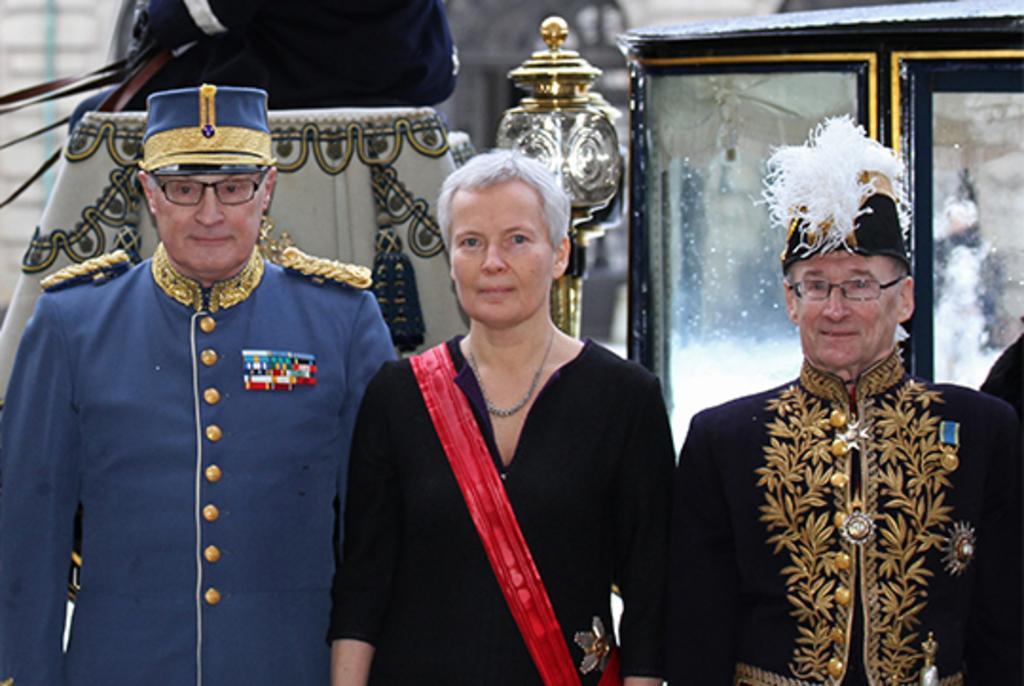How would you summarize this image in a sentence or two? In this picture there are three people standing. At the back there are objects and their might be a building. 